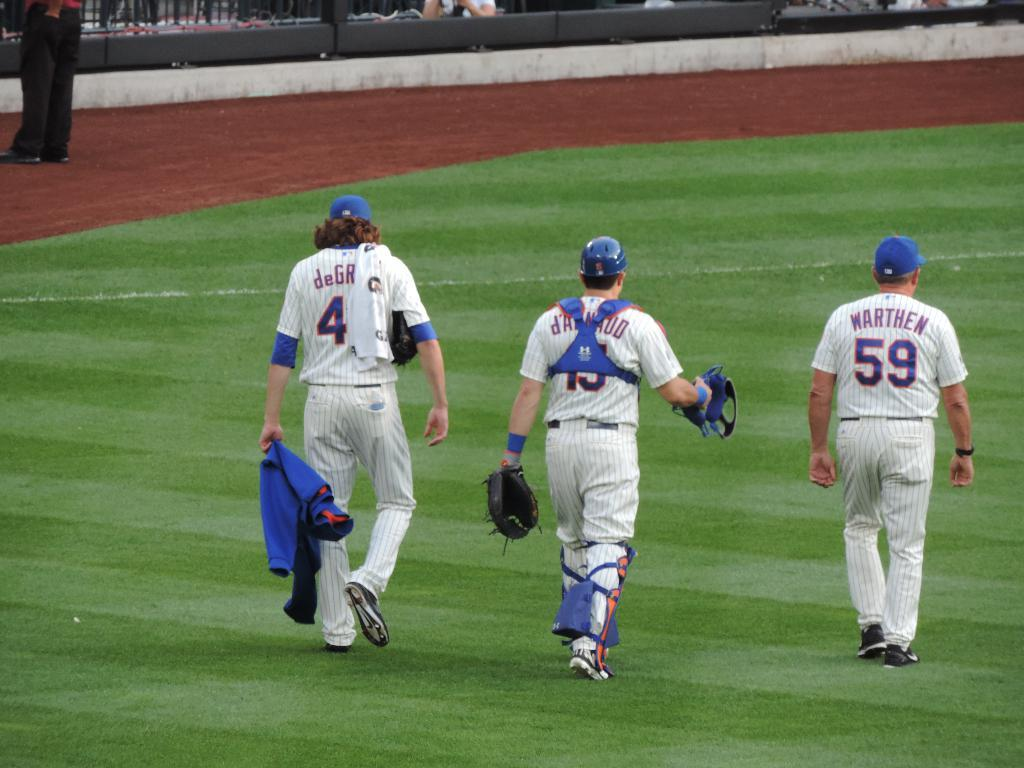Provide a one-sentence caption for the provided image. Coach Warthen walks on the field with his catcher and pitcher. 